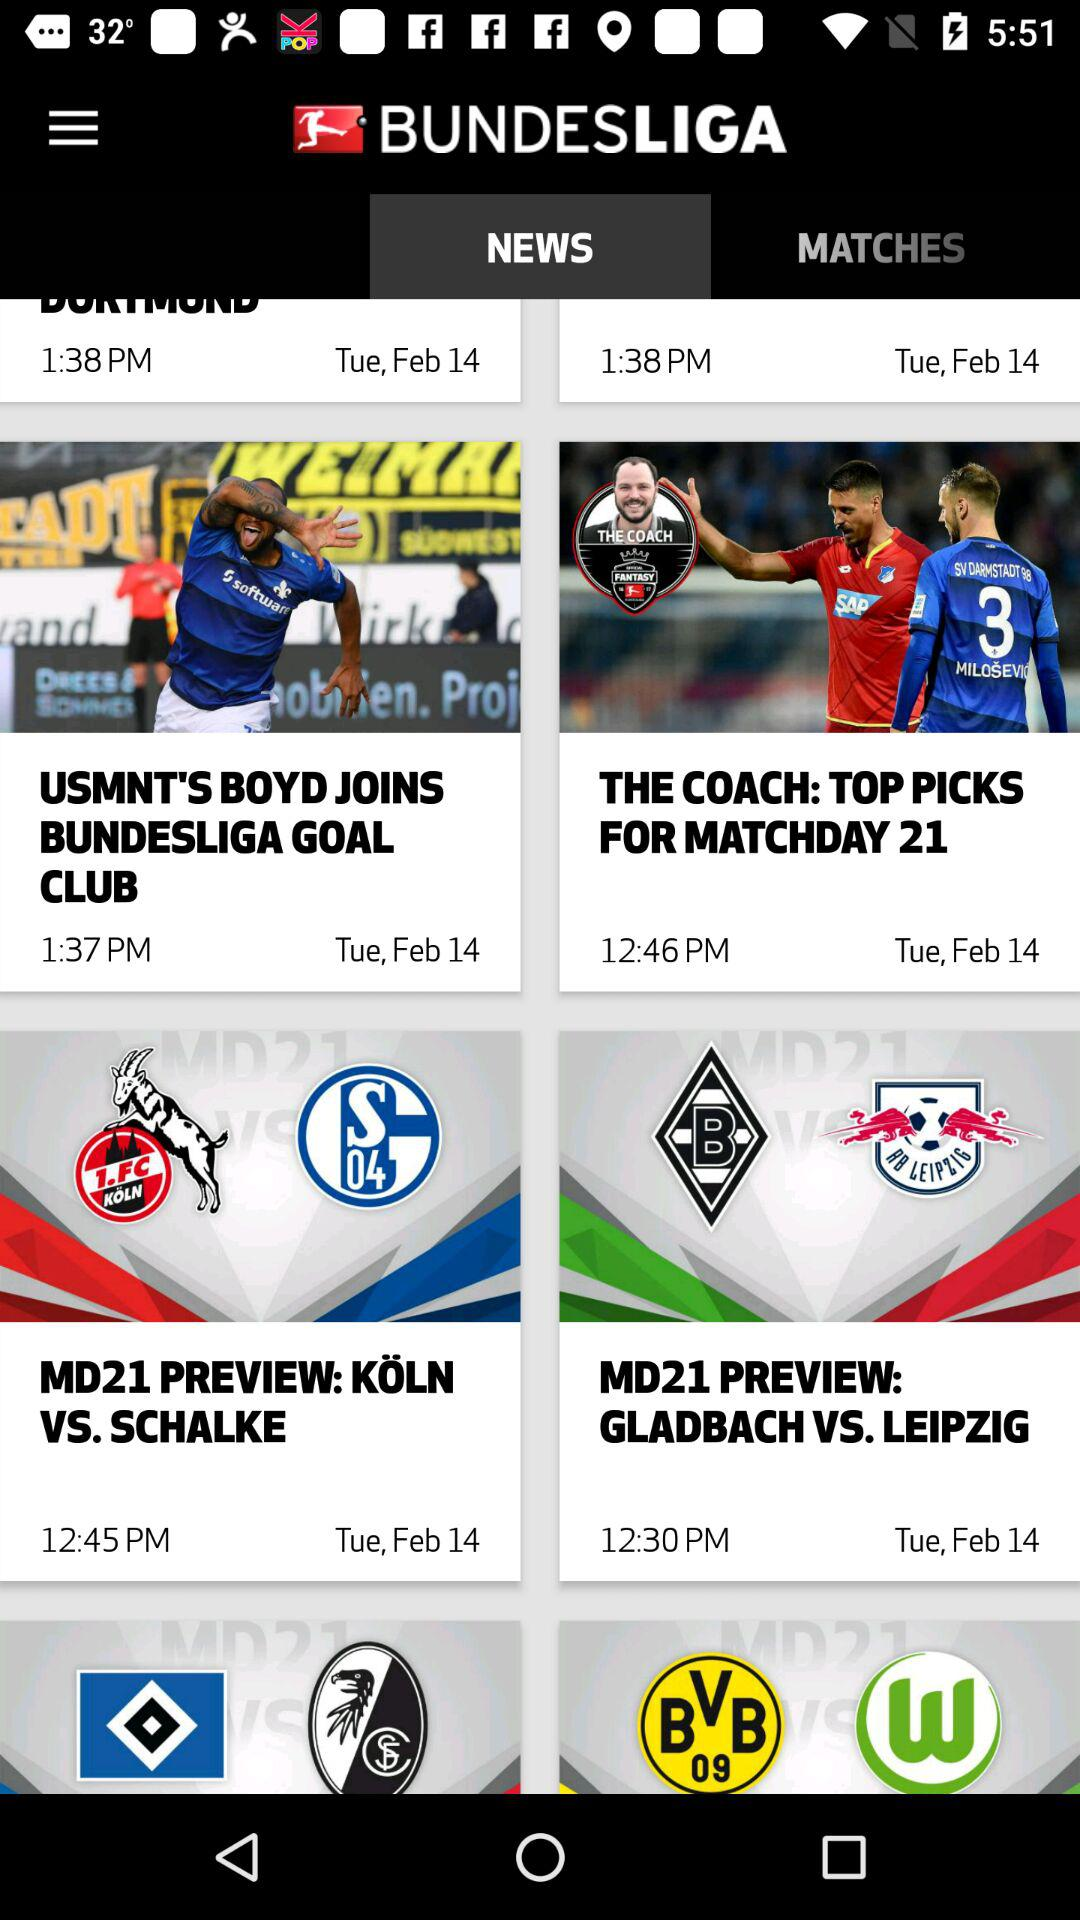Which tab is currently selected? Currently, the selected tab is "NEWS". 